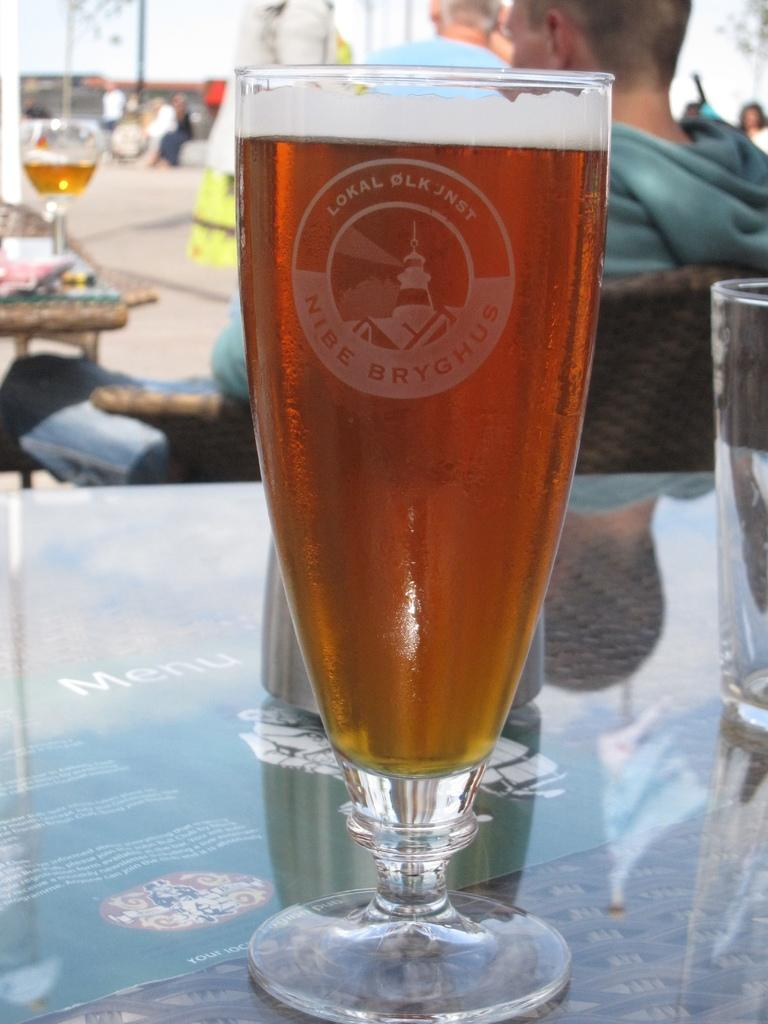What type of glass can be seen in the image? There is a beer glass in the image. Are there any other glasses visible? Yes, there is another glass in the image. Where are the glasses located? Both glasses are on a table. What else can be seen in the image? There is a man seated on a chair and another table with people seated near it. What type of club does the man use to crush the beetle in the image? There is no club or beetle present in the image. 